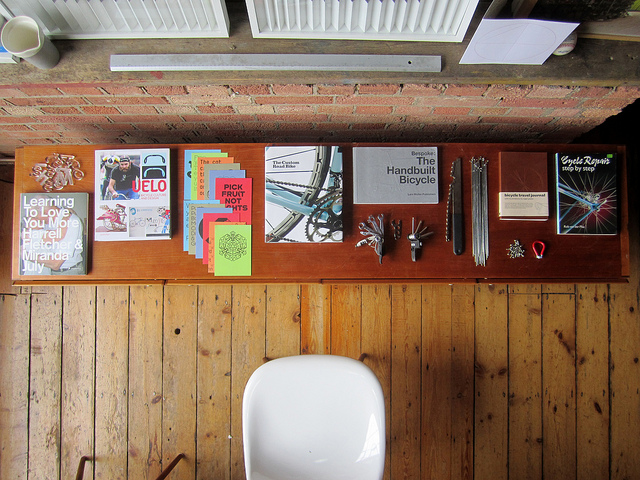Please extract the text content from this image. The Handbuilt Bicycle PICK JOLY Miranda & Harrell More You Love To Learning UELO HTS Not PRUCT Rojumit 